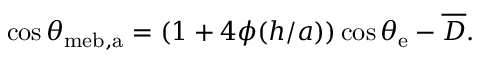Convert formula to latex. <formula><loc_0><loc_0><loc_500><loc_500>\cos \theta _ { m e b , a } = ( 1 + 4 \phi ( h / a ) ) \cos \theta _ { e } - \overline { D } .</formula> 